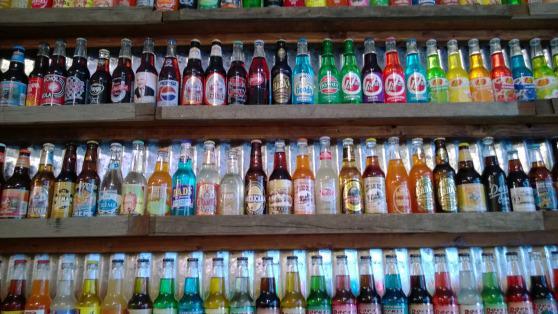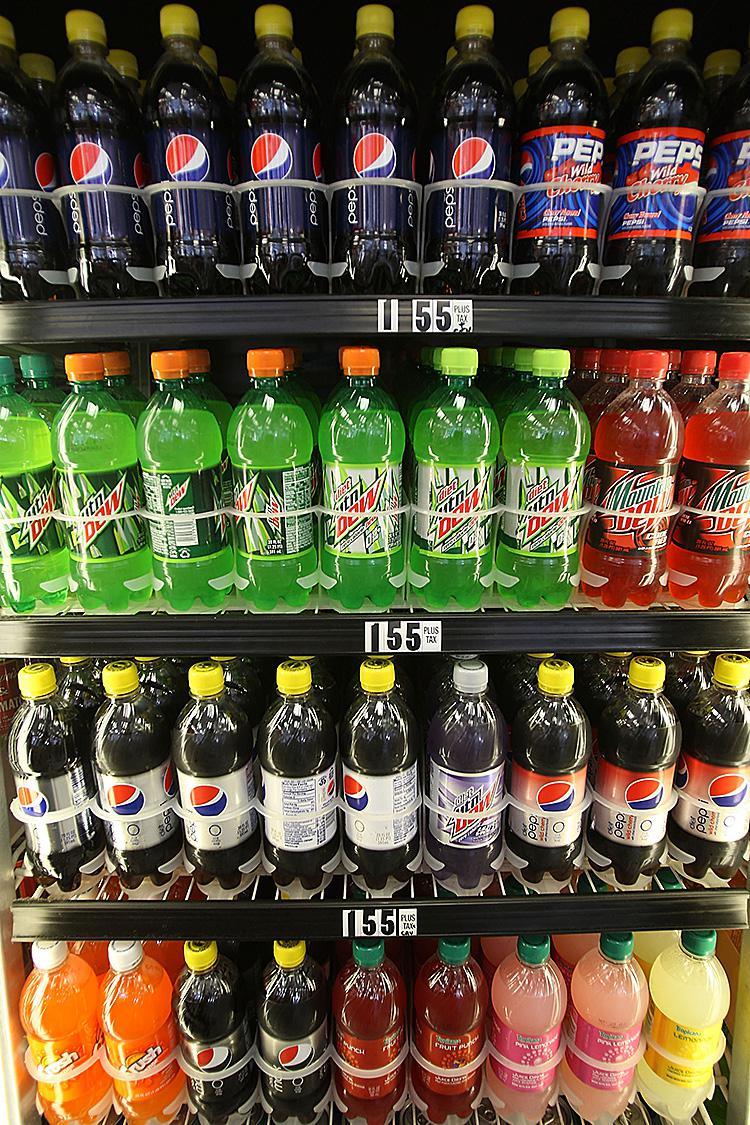The first image is the image on the left, the second image is the image on the right. Analyze the images presented: Is the assertion "There are no glass bottles in the right image." valid? Answer yes or no. Yes. The first image is the image on the left, the second image is the image on the right. Considering the images on both sides, is "There are lots of American brand, plastic soda bottles." valid? Answer yes or no. Yes. 